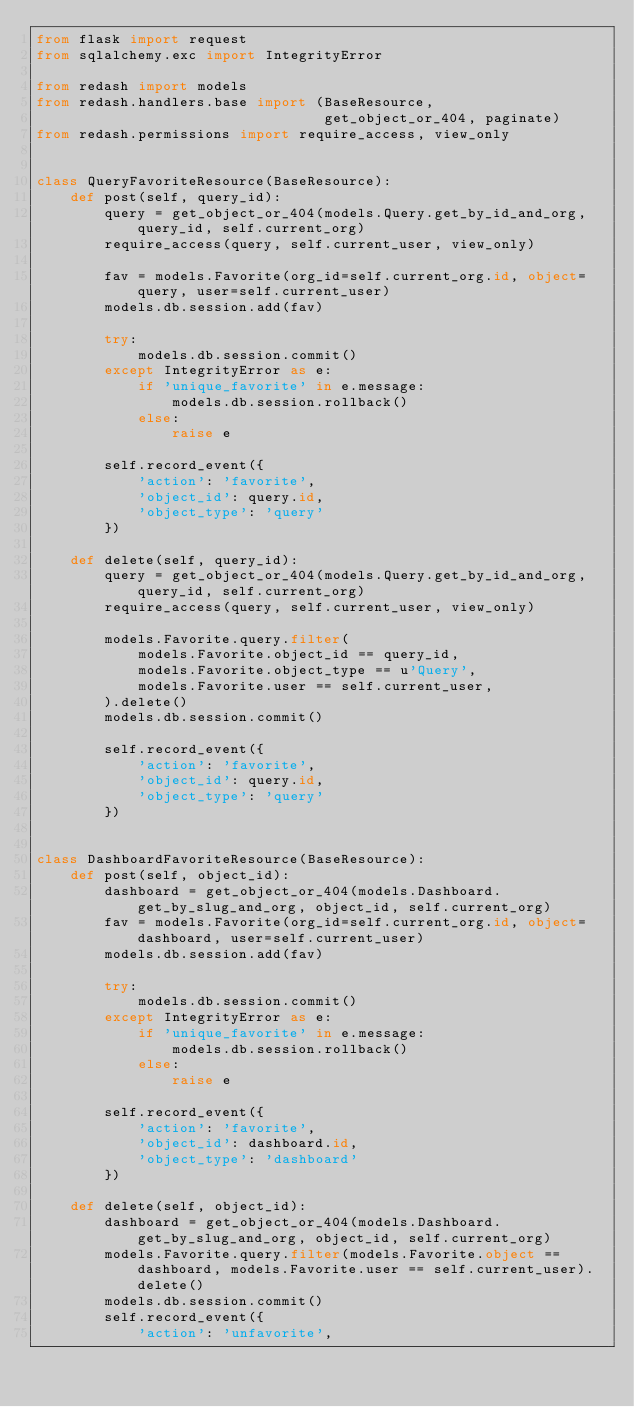Convert code to text. <code><loc_0><loc_0><loc_500><loc_500><_Python_>from flask import request
from sqlalchemy.exc import IntegrityError

from redash import models
from redash.handlers.base import (BaseResource,
                                  get_object_or_404, paginate)
from redash.permissions import require_access, view_only


class QueryFavoriteResource(BaseResource):
    def post(self, query_id):
        query = get_object_or_404(models.Query.get_by_id_and_org, query_id, self.current_org)
        require_access(query, self.current_user, view_only)

        fav = models.Favorite(org_id=self.current_org.id, object=query, user=self.current_user)
        models.db.session.add(fav)

        try:
            models.db.session.commit()
        except IntegrityError as e:
            if 'unique_favorite' in e.message:
                models.db.session.rollback()
            else:
                raise e

        self.record_event({
            'action': 'favorite',
            'object_id': query.id,
            'object_type': 'query'
        })

    def delete(self, query_id):
        query = get_object_or_404(models.Query.get_by_id_and_org, query_id, self.current_org)
        require_access(query, self.current_user, view_only)

        models.Favorite.query.filter(
            models.Favorite.object_id == query_id,
            models.Favorite.object_type == u'Query',
            models.Favorite.user == self.current_user,
        ).delete()
        models.db.session.commit()

        self.record_event({
            'action': 'favorite',
            'object_id': query.id,
            'object_type': 'query'
        })


class DashboardFavoriteResource(BaseResource):
    def post(self, object_id):
        dashboard = get_object_or_404(models.Dashboard.get_by_slug_and_org, object_id, self.current_org)
        fav = models.Favorite(org_id=self.current_org.id, object=dashboard, user=self.current_user)
        models.db.session.add(fav)

        try:
            models.db.session.commit()
        except IntegrityError as e:
            if 'unique_favorite' in e.message:
                models.db.session.rollback()
            else:
                raise e

        self.record_event({
            'action': 'favorite',
            'object_id': dashboard.id,
            'object_type': 'dashboard'
        })

    def delete(self, object_id):
        dashboard = get_object_or_404(models.Dashboard.get_by_slug_and_org, object_id, self.current_org)
        models.Favorite.query.filter(models.Favorite.object == dashboard, models.Favorite.user == self.current_user).delete()
        models.db.session.commit()
        self.record_event({
            'action': 'unfavorite',</code> 